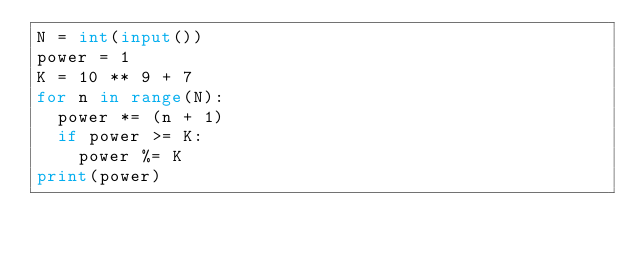<code> <loc_0><loc_0><loc_500><loc_500><_Python_>N = int(input())
power = 1
K = 10 ** 9 + 7
for n in range(N):
  power *= (n + 1)
  if power >= K:
    power %= K
print(power)</code> 